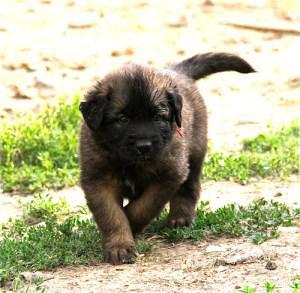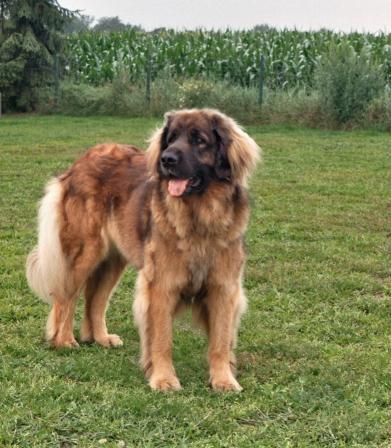The first image is the image on the left, the second image is the image on the right. Evaluate the accuracy of this statement regarding the images: "A dog is standing on the grass.". Is it true? Answer yes or no. Yes. The first image is the image on the left, the second image is the image on the right. Given the left and right images, does the statement "An image shows one person to the left of a large dog." hold true? Answer yes or no. No. 